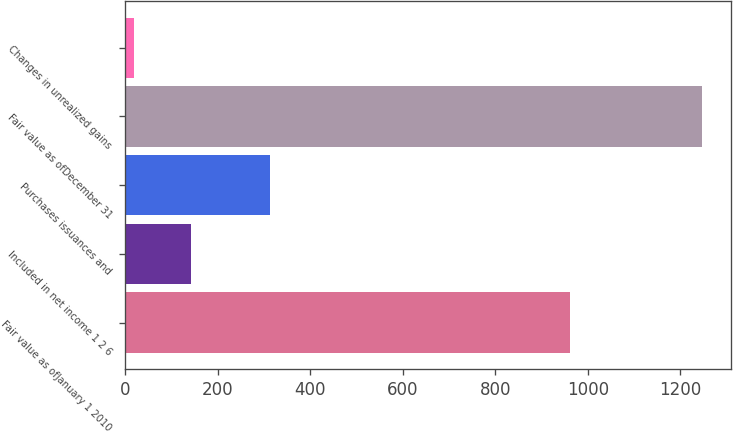Convert chart to OTSL. <chart><loc_0><loc_0><loc_500><loc_500><bar_chart><fcel>Fair value as ofJanuary 1 2010<fcel>Included in net income 1 2 6<fcel>Purchases issuances and<fcel>Fair value as ofDecember 31<fcel>Changes in unrealized gains<nl><fcel>962<fcel>142.7<fcel>314<fcel>1247<fcel>20<nl></chart> 